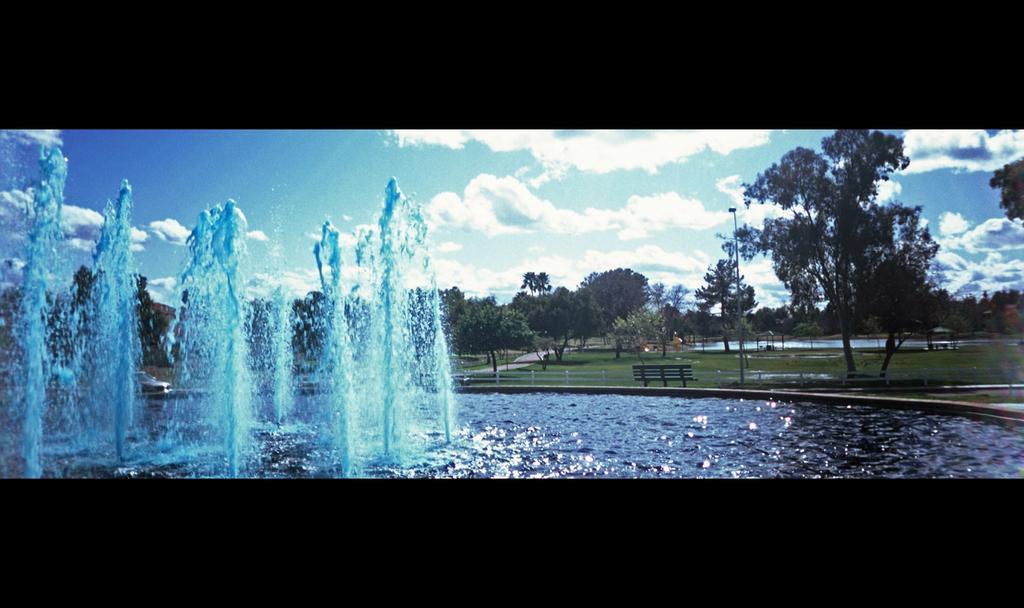Could you give a brief overview of what you see in this image? In this image we can see a fountain with water. In the background of the image there are trees, sky and clouds. There is a bench. There is a pole. 